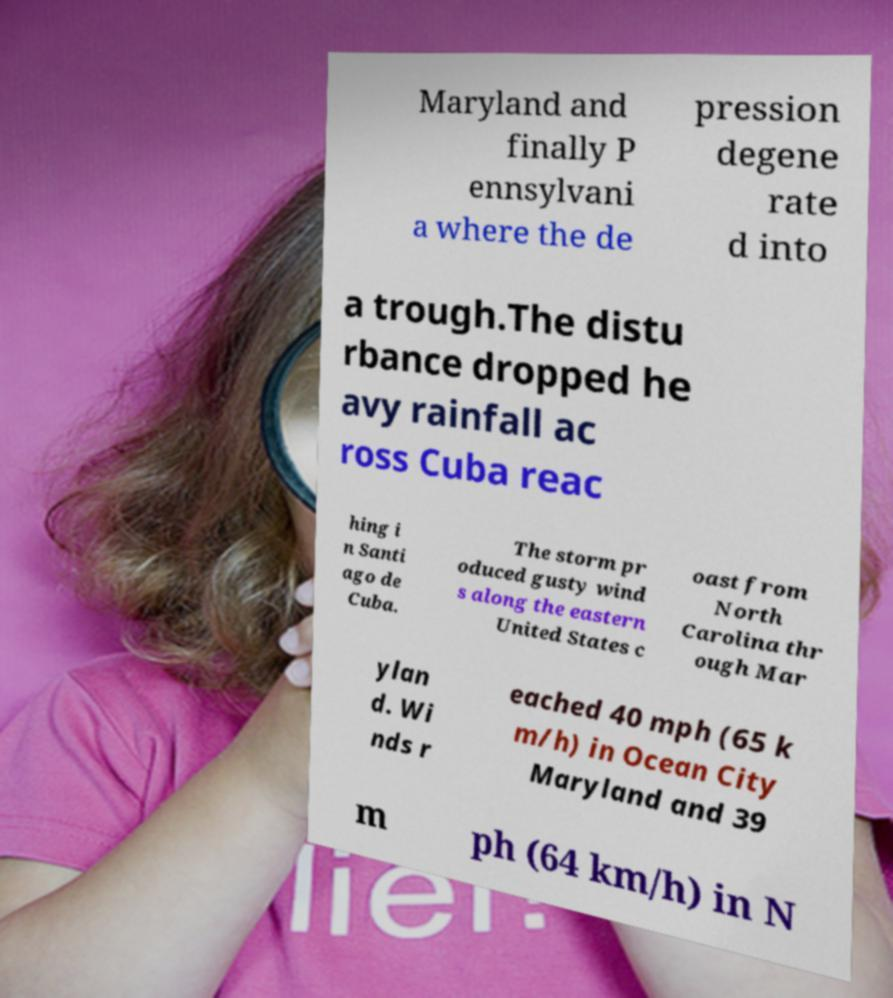Could you extract and type out the text from this image? Maryland and finally P ennsylvani a where the de pression degene rate d into a trough.The distu rbance dropped he avy rainfall ac ross Cuba reac hing i n Santi ago de Cuba. The storm pr oduced gusty wind s along the eastern United States c oast from North Carolina thr ough Mar ylan d. Wi nds r eached 40 mph (65 k m/h) in Ocean City Maryland and 39 m ph (64 km/h) in N 